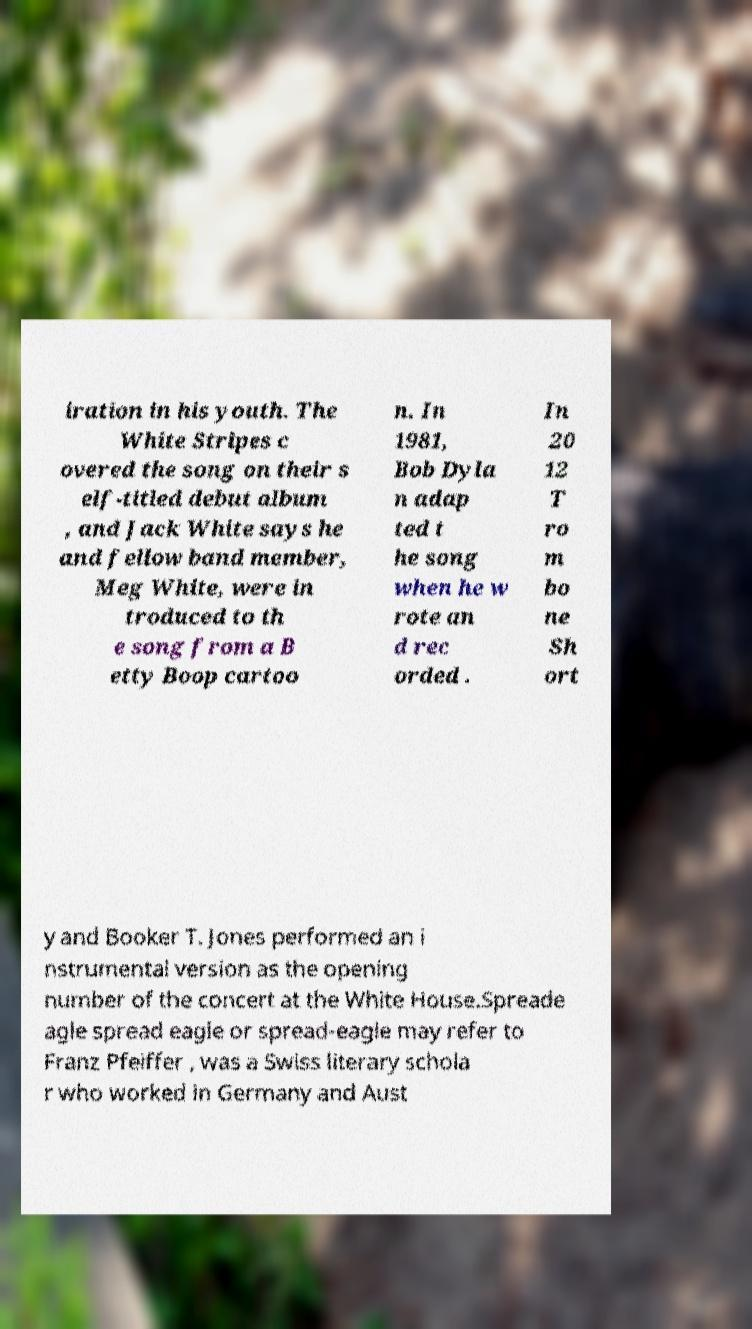For documentation purposes, I need the text within this image transcribed. Could you provide that? iration in his youth. The White Stripes c overed the song on their s elf-titled debut album , and Jack White says he and fellow band member, Meg White, were in troduced to th e song from a B etty Boop cartoo n. In 1981, Bob Dyla n adap ted t he song when he w rote an d rec orded . In 20 12 T ro m bo ne Sh ort y and Booker T. Jones performed an i nstrumental version as the opening number of the concert at the White House.Spreade agle spread eagle or spread-eagle may refer to Franz Pfeiffer , was a Swiss literary schola r who worked in Germany and Aust 